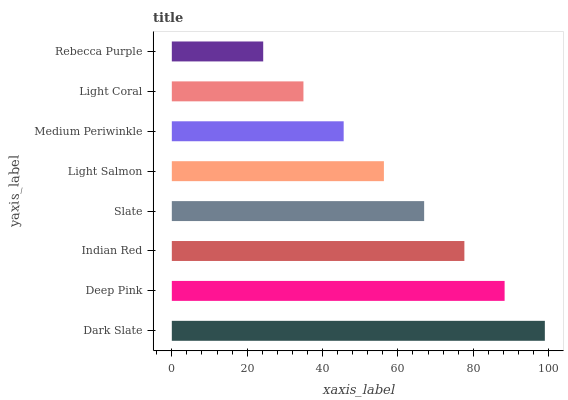Is Rebecca Purple the minimum?
Answer yes or no. Yes. Is Dark Slate the maximum?
Answer yes or no. Yes. Is Deep Pink the minimum?
Answer yes or no. No. Is Deep Pink the maximum?
Answer yes or no. No. Is Dark Slate greater than Deep Pink?
Answer yes or no. Yes. Is Deep Pink less than Dark Slate?
Answer yes or no. Yes. Is Deep Pink greater than Dark Slate?
Answer yes or no. No. Is Dark Slate less than Deep Pink?
Answer yes or no. No. Is Slate the high median?
Answer yes or no. Yes. Is Light Salmon the low median?
Answer yes or no. Yes. Is Dark Slate the high median?
Answer yes or no. No. Is Dark Slate the low median?
Answer yes or no. No. 